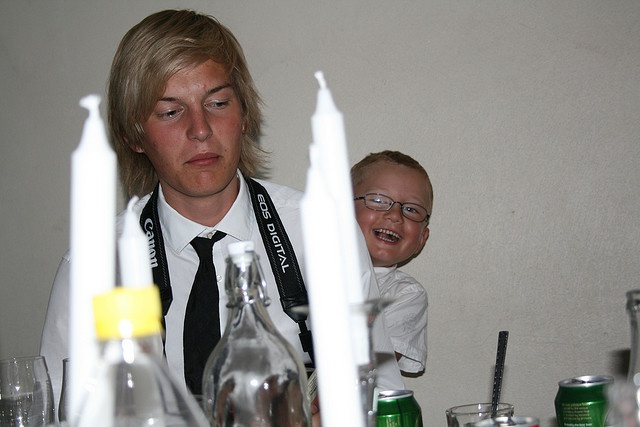Describe the objects in this image and their specific colors. I can see people in gray, black, darkgray, brown, and maroon tones, people in gray, darkgray, and brown tones, bottle in gray, darkgray, ivory, and khaki tones, bottle in gray, darkgray, black, and lightgray tones, and tie in gray and black tones in this image. 